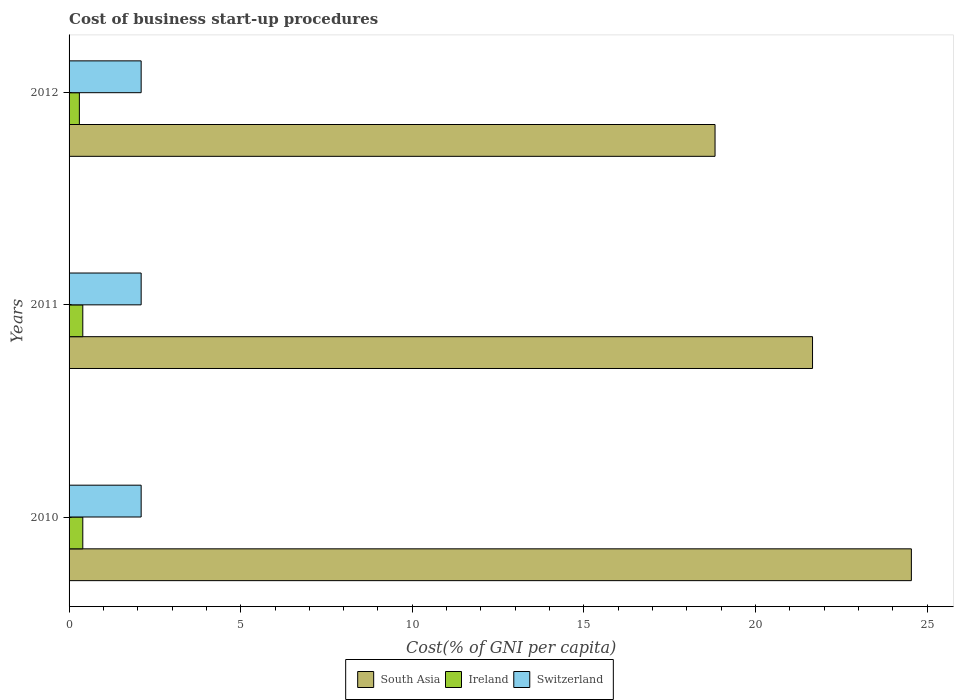How many groups of bars are there?
Provide a short and direct response. 3. How many bars are there on the 2nd tick from the top?
Provide a short and direct response. 3. In how many cases, is the number of bars for a given year not equal to the number of legend labels?
Make the answer very short. 0. What is the cost of business start-up procedures in South Asia in 2010?
Make the answer very short. 24.54. Across all years, what is the maximum cost of business start-up procedures in Switzerland?
Provide a short and direct response. 2.1. Across all years, what is the minimum cost of business start-up procedures in South Asia?
Offer a terse response. 18.82. What is the total cost of business start-up procedures in South Asia in the graph?
Your response must be concise. 65.02. What is the difference between the cost of business start-up procedures in South Asia in 2010 and that in 2011?
Make the answer very short. 2.88. What is the difference between the cost of business start-up procedures in Ireland in 2010 and the cost of business start-up procedures in South Asia in 2012?
Your answer should be very brief. -18.42. In the year 2010, what is the difference between the cost of business start-up procedures in Switzerland and cost of business start-up procedures in South Asia?
Your response must be concise. -22.44. What is the ratio of the cost of business start-up procedures in Ireland in 2011 to that in 2012?
Offer a terse response. 1.33. What is the difference between the highest and the second highest cost of business start-up procedures in Switzerland?
Provide a succinct answer. 0. What is the difference between the highest and the lowest cost of business start-up procedures in South Asia?
Ensure brevity in your answer.  5.72. What does the 1st bar from the top in 2012 represents?
Your answer should be compact. Switzerland. How many years are there in the graph?
Your answer should be compact. 3. What is the difference between two consecutive major ticks on the X-axis?
Your answer should be compact. 5. Are the values on the major ticks of X-axis written in scientific E-notation?
Make the answer very short. No. Does the graph contain any zero values?
Offer a very short reply. No. Does the graph contain grids?
Make the answer very short. No. What is the title of the graph?
Your answer should be compact. Cost of business start-up procedures. Does "Brazil" appear as one of the legend labels in the graph?
Your answer should be compact. No. What is the label or title of the X-axis?
Keep it short and to the point. Cost(% of GNI per capita). What is the label or title of the Y-axis?
Keep it short and to the point. Years. What is the Cost(% of GNI per capita) in South Asia in 2010?
Offer a terse response. 24.54. What is the Cost(% of GNI per capita) in Ireland in 2010?
Ensure brevity in your answer.  0.4. What is the Cost(% of GNI per capita) in South Asia in 2011?
Keep it short and to the point. 21.66. What is the Cost(% of GNI per capita) of Ireland in 2011?
Your answer should be very brief. 0.4. What is the Cost(% of GNI per capita) of South Asia in 2012?
Your answer should be compact. 18.82. What is the Cost(% of GNI per capita) of Ireland in 2012?
Make the answer very short. 0.3. Across all years, what is the maximum Cost(% of GNI per capita) in South Asia?
Make the answer very short. 24.54. Across all years, what is the maximum Cost(% of GNI per capita) in Ireland?
Make the answer very short. 0.4. Across all years, what is the minimum Cost(% of GNI per capita) of South Asia?
Offer a terse response. 18.82. Across all years, what is the minimum Cost(% of GNI per capita) of Ireland?
Offer a terse response. 0.3. What is the total Cost(% of GNI per capita) in South Asia in the graph?
Provide a short and direct response. 65.02. What is the total Cost(% of GNI per capita) in Ireland in the graph?
Provide a short and direct response. 1.1. What is the total Cost(% of GNI per capita) of Switzerland in the graph?
Your response must be concise. 6.3. What is the difference between the Cost(% of GNI per capita) of South Asia in 2010 and that in 2011?
Your answer should be compact. 2.88. What is the difference between the Cost(% of GNI per capita) in South Asia in 2010 and that in 2012?
Make the answer very short. 5.72. What is the difference between the Cost(% of GNI per capita) in Ireland in 2010 and that in 2012?
Your answer should be very brief. 0.1. What is the difference between the Cost(% of GNI per capita) in Switzerland in 2010 and that in 2012?
Offer a very short reply. 0. What is the difference between the Cost(% of GNI per capita) in South Asia in 2011 and that in 2012?
Keep it short and to the point. 2.84. What is the difference between the Cost(% of GNI per capita) in Ireland in 2011 and that in 2012?
Your response must be concise. 0.1. What is the difference between the Cost(% of GNI per capita) of Switzerland in 2011 and that in 2012?
Provide a succinct answer. 0. What is the difference between the Cost(% of GNI per capita) of South Asia in 2010 and the Cost(% of GNI per capita) of Ireland in 2011?
Give a very brief answer. 24.14. What is the difference between the Cost(% of GNI per capita) of South Asia in 2010 and the Cost(% of GNI per capita) of Switzerland in 2011?
Your response must be concise. 22.44. What is the difference between the Cost(% of GNI per capita) of South Asia in 2010 and the Cost(% of GNI per capita) of Ireland in 2012?
Keep it short and to the point. 24.24. What is the difference between the Cost(% of GNI per capita) in South Asia in 2010 and the Cost(% of GNI per capita) in Switzerland in 2012?
Make the answer very short. 22.44. What is the difference between the Cost(% of GNI per capita) in Ireland in 2010 and the Cost(% of GNI per capita) in Switzerland in 2012?
Ensure brevity in your answer.  -1.7. What is the difference between the Cost(% of GNI per capita) in South Asia in 2011 and the Cost(% of GNI per capita) in Ireland in 2012?
Keep it short and to the point. 21.36. What is the difference between the Cost(% of GNI per capita) in South Asia in 2011 and the Cost(% of GNI per capita) in Switzerland in 2012?
Provide a succinct answer. 19.56. What is the difference between the Cost(% of GNI per capita) of Ireland in 2011 and the Cost(% of GNI per capita) of Switzerland in 2012?
Keep it short and to the point. -1.7. What is the average Cost(% of GNI per capita) in South Asia per year?
Ensure brevity in your answer.  21.67. What is the average Cost(% of GNI per capita) of Ireland per year?
Provide a short and direct response. 0.37. In the year 2010, what is the difference between the Cost(% of GNI per capita) of South Asia and Cost(% of GNI per capita) of Ireland?
Your response must be concise. 24.14. In the year 2010, what is the difference between the Cost(% of GNI per capita) in South Asia and Cost(% of GNI per capita) in Switzerland?
Provide a short and direct response. 22.44. In the year 2010, what is the difference between the Cost(% of GNI per capita) of Ireland and Cost(% of GNI per capita) of Switzerland?
Your answer should be compact. -1.7. In the year 2011, what is the difference between the Cost(% of GNI per capita) in South Asia and Cost(% of GNI per capita) in Ireland?
Offer a terse response. 21.26. In the year 2011, what is the difference between the Cost(% of GNI per capita) in South Asia and Cost(% of GNI per capita) in Switzerland?
Offer a very short reply. 19.56. In the year 2012, what is the difference between the Cost(% of GNI per capita) in South Asia and Cost(% of GNI per capita) in Ireland?
Your response must be concise. 18.52. In the year 2012, what is the difference between the Cost(% of GNI per capita) of South Asia and Cost(% of GNI per capita) of Switzerland?
Your response must be concise. 16.72. What is the ratio of the Cost(% of GNI per capita) of South Asia in 2010 to that in 2011?
Your answer should be very brief. 1.13. What is the ratio of the Cost(% of GNI per capita) in Switzerland in 2010 to that in 2011?
Your response must be concise. 1. What is the ratio of the Cost(% of GNI per capita) in South Asia in 2010 to that in 2012?
Provide a succinct answer. 1.3. What is the ratio of the Cost(% of GNI per capita) in Ireland in 2010 to that in 2012?
Your response must be concise. 1.33. What is the ratio of the Cost(% of GNI per capita) of Switzerland in 2010 to that in 2012?
Provide a succinct answer. 1. What is the ratio of the Cost(% of GNI per capita) in South Asia in 2011 to that in 2012?
Your response must be concise. 1.15. What is the ratio of the Cost(% of GNI per capita) in Ireland in 2011 to that in 2012?
Your answer should be compact. 1.33. What is the difference between the highest and the second highest Cost(% of GNI per capita) in South Asia?
Keep it short and to the point. 2.88. What is the difference between the highest and the lowest Cost(% of GNI per capita) in South Asia?
Your answer should be very brief. 5.72. What is the difference between the highest and the lowest Cost(% of GNI per capita) in Ireland?
Make the answer very short. 0.1. 